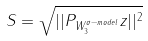Convert formula to latex. <formula><loc_0><loc_0><loc_500><loc_500>S = \sqrt { | | P _ { W _ { 3 } ^ { \sigma - m o d e l } } z | | ^ { 2 } }</formula> 